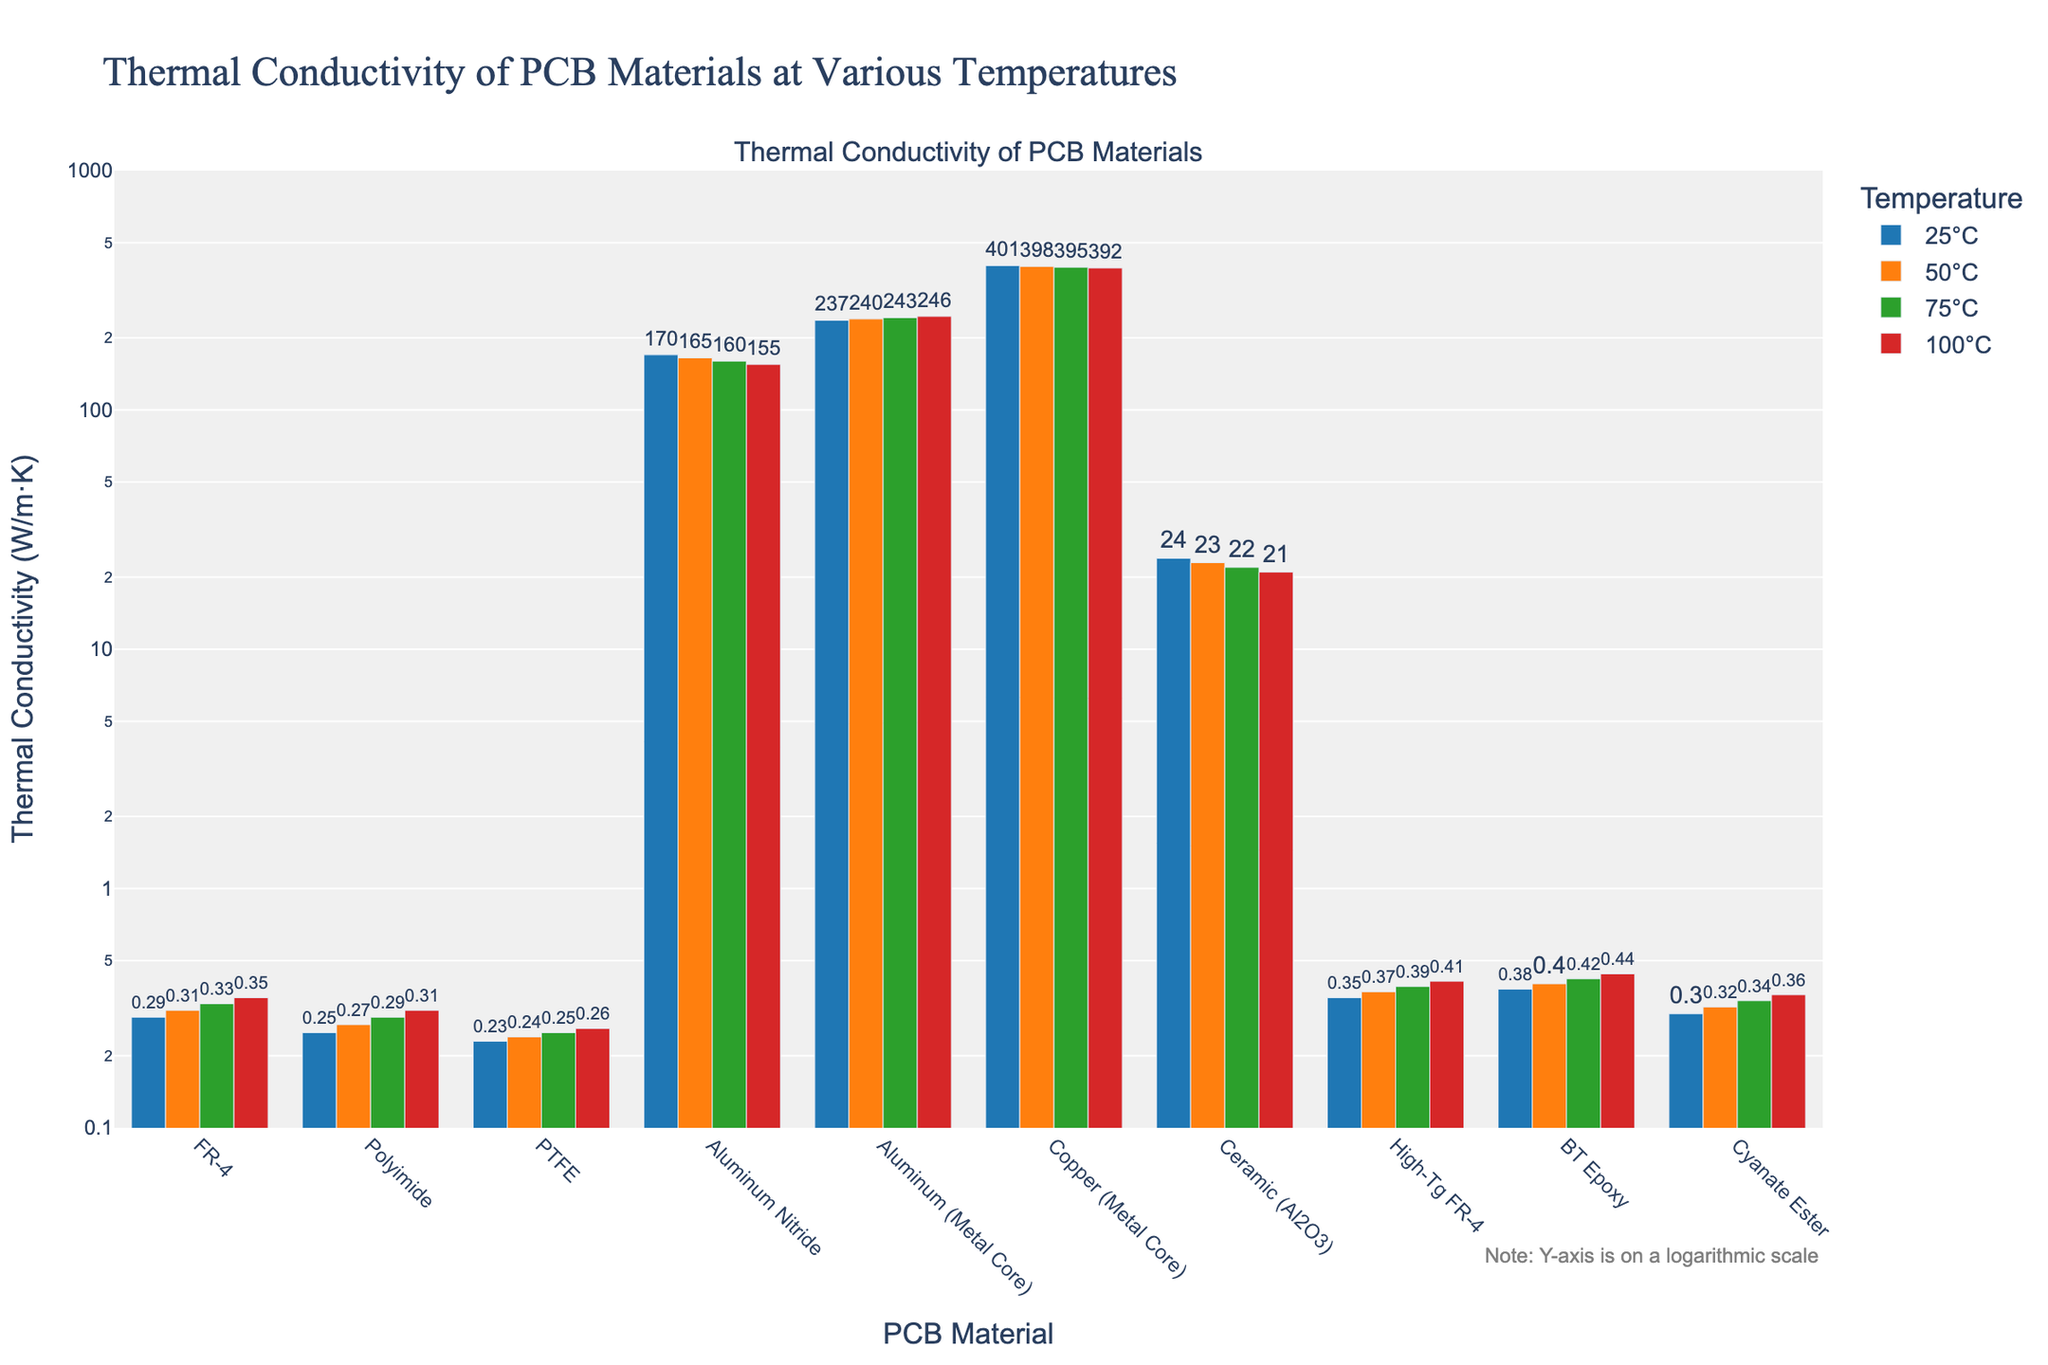Which material has the highest thermal conductivity at 25°C? The tallest bar in the bar chart for the 25°C temperature condition represents the material with the highest thermal conductivity. In this case, it is "Copper (Metal Core)" which is significantly higher than others.
Answer: Copper (Metal Core) Which material shows the least increase in thermal conductivity from 25°C to 100°C? To determine this, we need to compare the differences in thermal conductivity from 25°C to 100°C for each material. PTFE changes from 0.23 W/m·K at 25°C to 0.26 W/m·K at 100°C, an increase of 0.03 W/m·K, which is the smallest increase.
Answer: PTFE By how much does the thermal conductivity of Aluminum (Metal Core) change from 25°C to 100°C? The change can be calculated by subtracting the thermal conductivity at 25°C from that at 100°C for Aluminum (Metal Core). This is 246 - 237 = 9 W/m·K.
Answer: 9 W/m·K What is the average thermal conductivity of Polyimide at all given temperatures? To find the average, sum up the thermal conductivities of Polyimide at all temperatures and then divide by the number of temperature points: (0.25 + 0.27 + 0.29 + 0.31) / 4 = 1.12 / 4 = 0.28 W/m·K
Answer: 0.28 W/m·K Which material demonstrates the highest thermal conductivity decrease as temperature increases from 25°C to 100°C? To find this, we subtract the thermal conductivity at 100°C from that at 25°C for each material and identify the maximum decrease. For Aluminum Nitride, this is 170 - 155 = 15 W/m·K, which is the highest.
Answer: Aluminum Nitride How does the thermal conductivity of Ceramic (Al2O3) at 75°C compare to that at 25°C? The thermal conductivity of Ceramic (Al2O3) at 75°C is 22 W/m·K, and at 25°C it is 24 W/m·K. Therefore, the conductivity decreases by 2 W/m·K.
Answer: Decreases by 2 W/m·K Between High-Tg FR-4 and BT Epoxy, which has the higher thermal conductivity at 100°C? By comparing the bars representing High-Tg FR-4 and BT Epoxy at 100°C, we can see that BT Epoxy has a thermal conductivity of 0.44 W/m·K, which is higher than the 0.41 W/m·K of High-Tg FR-4.
Answer: BT Epoxy Which material shows a consistent decrease in thermal conductivity with increasing temperature? By analyzing the bars for each material, we see that both Aluminum Nitride and Ceramic (Al2O3) consistently show a decrease in thermal conductivity from 25°C to 100°C.
Answer: Aluminum Nitride, Ceramic (Al2O3) What is the total thermal conductivity of FR-4 and Cyanate Ester at 100°C? Add the thermal conductivity of FR-4 at 100°C (0.35 W/m·K) with that of Cyanate Ester (0.36 W/m·K): 0.35 + 0.36 = 0.71 W/m·K.
Answer: 0.71 W/m·K 